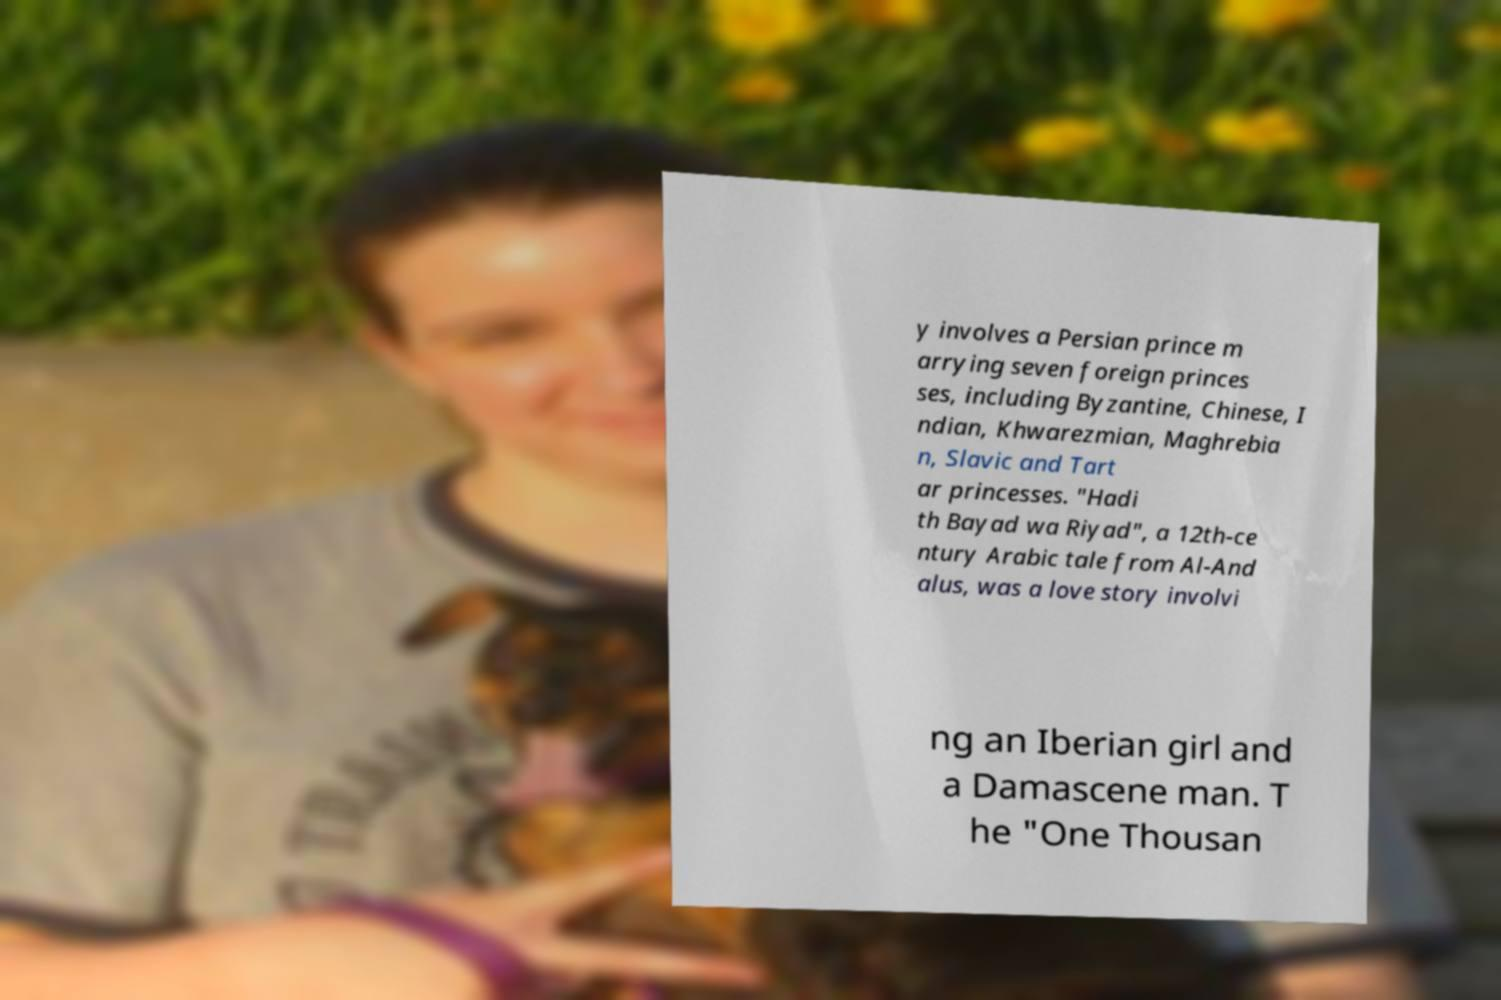There's text embedded in this image that I need extracted. Can you transcribe it verbatim? y involves a Persian prince m arrying seven foreign princes ses, including Byzantine, Chinese, I ndian, Khwarezmian, Maghrebia n, Slavic and Tart ar princesses. "Hadi th Bayad wa Riyad", a 12th-ce ntury Arabic tale from Al-And alus, was a love story involvi ng an Iberian girl and a Damascene man. T he "One Thousan 